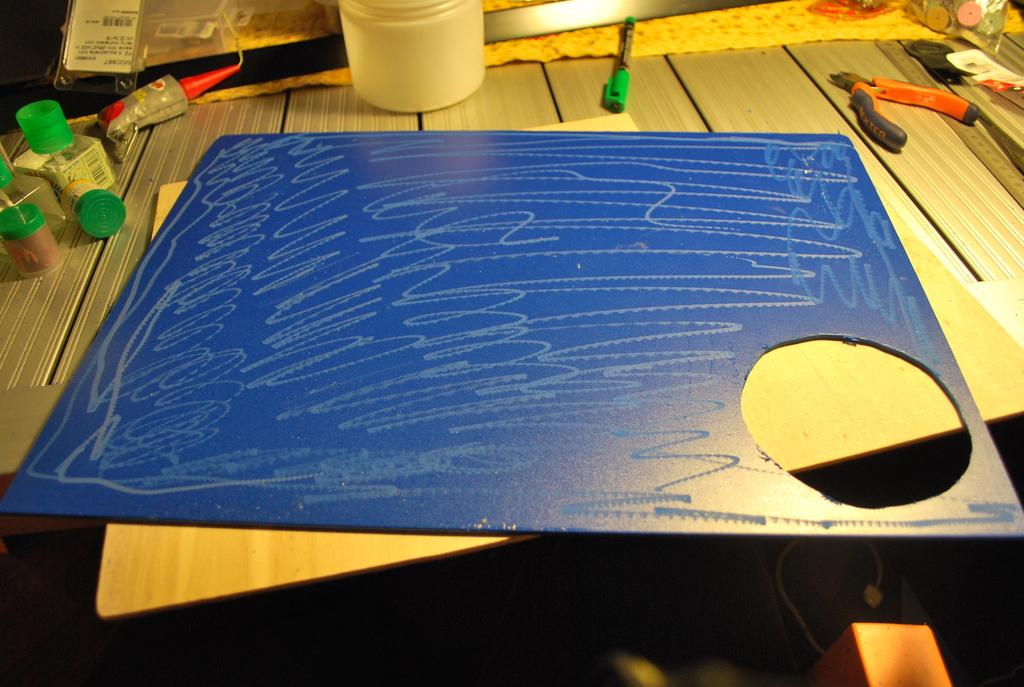What type of furniture is in the image? There is a table in the image. What is on top of the table? The table contains a board, bottles, a pen, and a pliers tool. What type of writing instrument is on the table? There is a pen on the table. What type of tool is on the table? A pliers tool is present on the table. What lesson is the son teaching to the passenger in the image? There is no reference to a son or passenger in the image; it only features a table with various objects on it. 